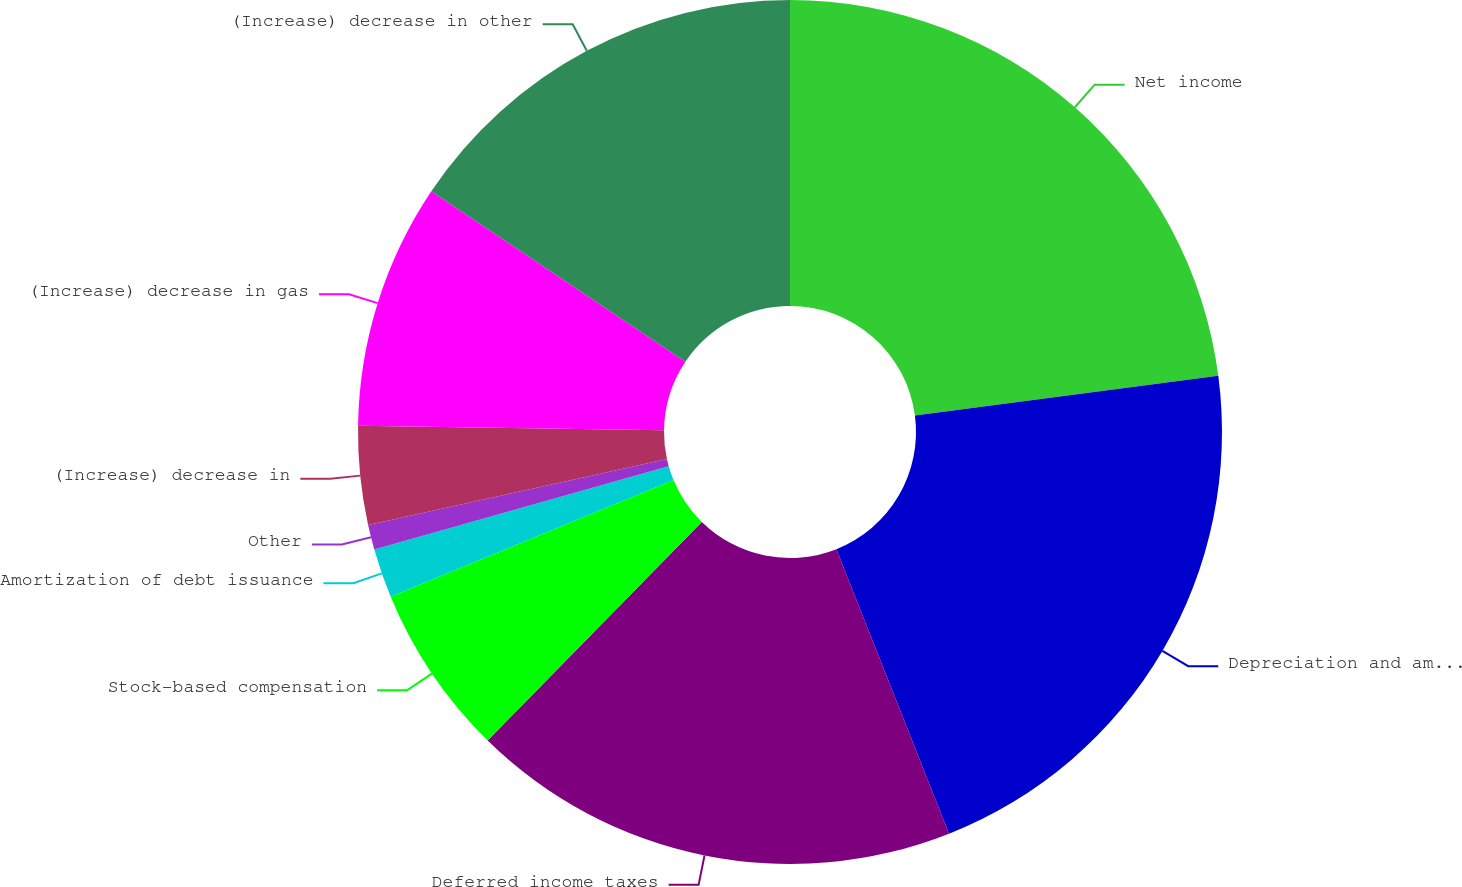Convert chart. <chart><loc_0><loc_0><loc_500><loc_500><pie_chart><fcel>Net income<fcel>Depreciation and amortization<fcel>Deferred income taxes<fcel>Stock-based compensation<fcel>Amortization of debt issuance<fcel>Other<fcel>(Increase) decrease in<fcel>(Increase) decrease in gas<fcel>(Increase) decrease in other<nl><fcel>22.92%<fcel>21.08%<fcel>18.34%<fcel>6.43%<fcel>1.85%<fcel>0.93%<fcel>3.68%<fcel>9.18%<fcel>15.59%<nl></chart> 